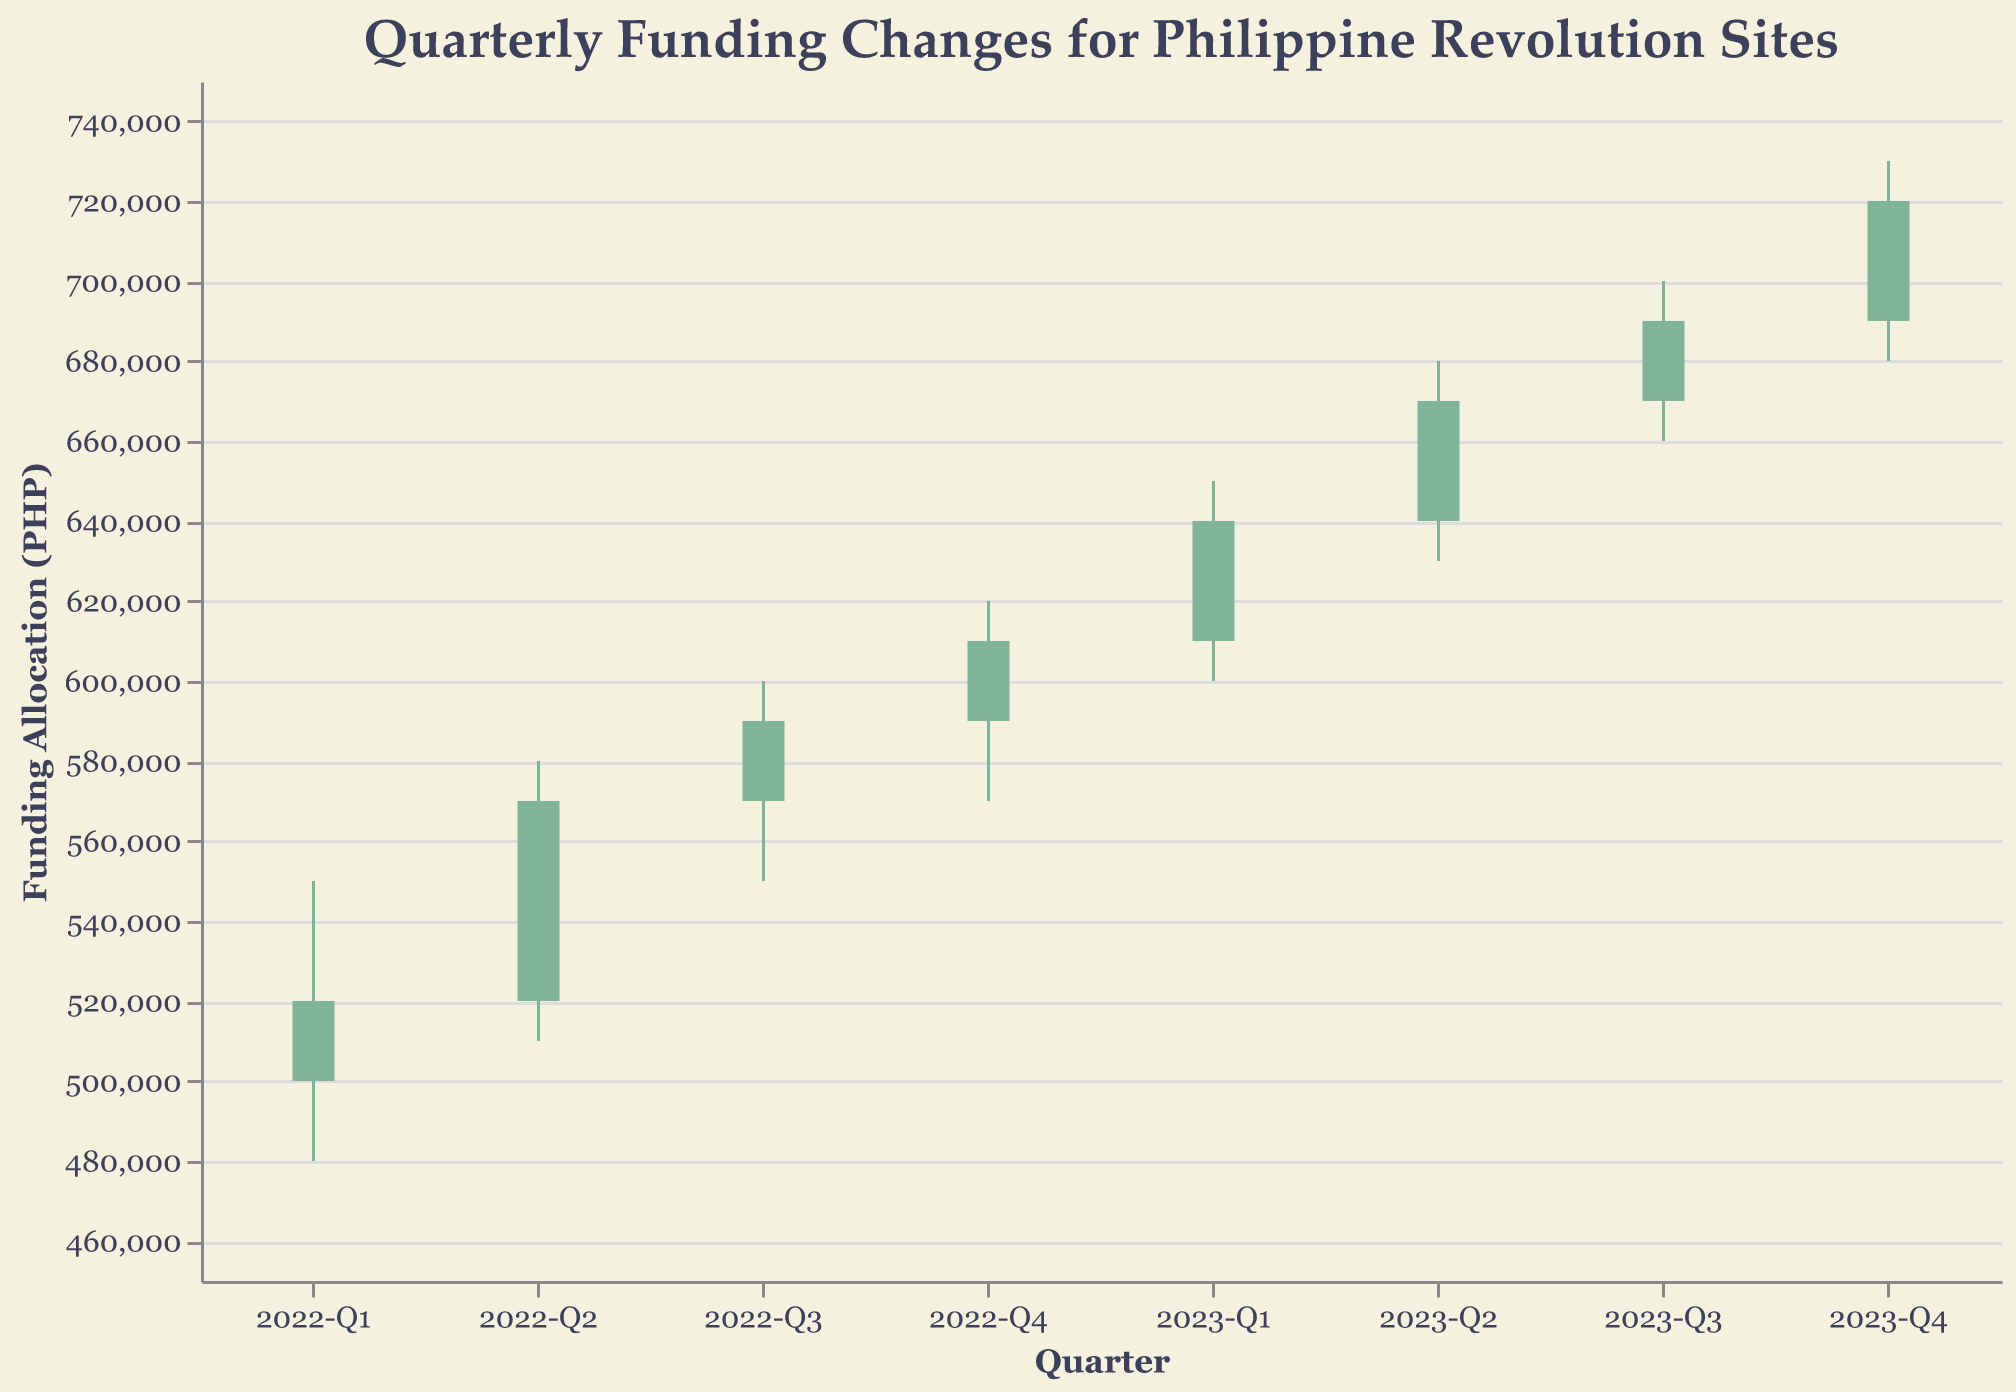What's the title of the chart? The title is usually located at the top of the chart. In this case, it states the focus of the data being displayed.
Answer: Quarterly Funding Changes for Philippine Revolution Sites What is the funding range displayed on the y-axis? The y-axis uses a range that encompasses the lowest and highest funding amounts shown in the data.
Answer: 450,000 to 750,000 PHP Which quarter had the highest funding allocation for a single project? The quarter with the highest close value indicates the highest funding allocation.
Answer: 2023-Q4 for Malolos Congress Site What is the project with the lowest funded quarter, and what was the low value for that quarter? The Low value in the data set indicates the lowest funding for a given quarter. By comparing all Low values, we identify the minimum.
Answer: 2022-Q1 for Aguinaldo Shrine, 480,000 PHP How did the funding change from 2022-Q1 to 2022-Q2 for the analyzed project? To see the change, compare the Close value of 2022-Q1 with the Open value of 2022-Q2.
Answer: Increased from 520,000 to 570,000 PHP Which project had the widest range between its high and low values in a single quarter? Calculate (High - Low) for each quarter and identify the maximum
Answer: Malolos Congress Site in 2023-Q4 (730,000 - 680,000 = 50,000 PHP) What is the average funding allocation of the closing values for the year 2022? Sum the Close values for each quarter in 2022 (520,000, 570,000, 590,000, 610,000) and divide by 4.
Answer: 572,500 PHP Which quarter had the funding allocation decrease compared to its opening value and what was the project? Look for quarters where the Close value is less than the Open value. There’s only one such occurrence in the data.
Answer: 2022-Q1 for Aguinaldo Shrine Which project observed the highest increase in funding from one quarter to the next? Inspect the change from the Close value of one quarter to the Open value of the next quarter, comparing all transitions.
Answer: Aguinaldo Shrine from 2022-Q1 to 2022-Q2 How many quarters experienced an increase in funding allocation from start to close? Count the instances where the Close value is greater than the Open value for each quarter.
Answer: 7 quarters 